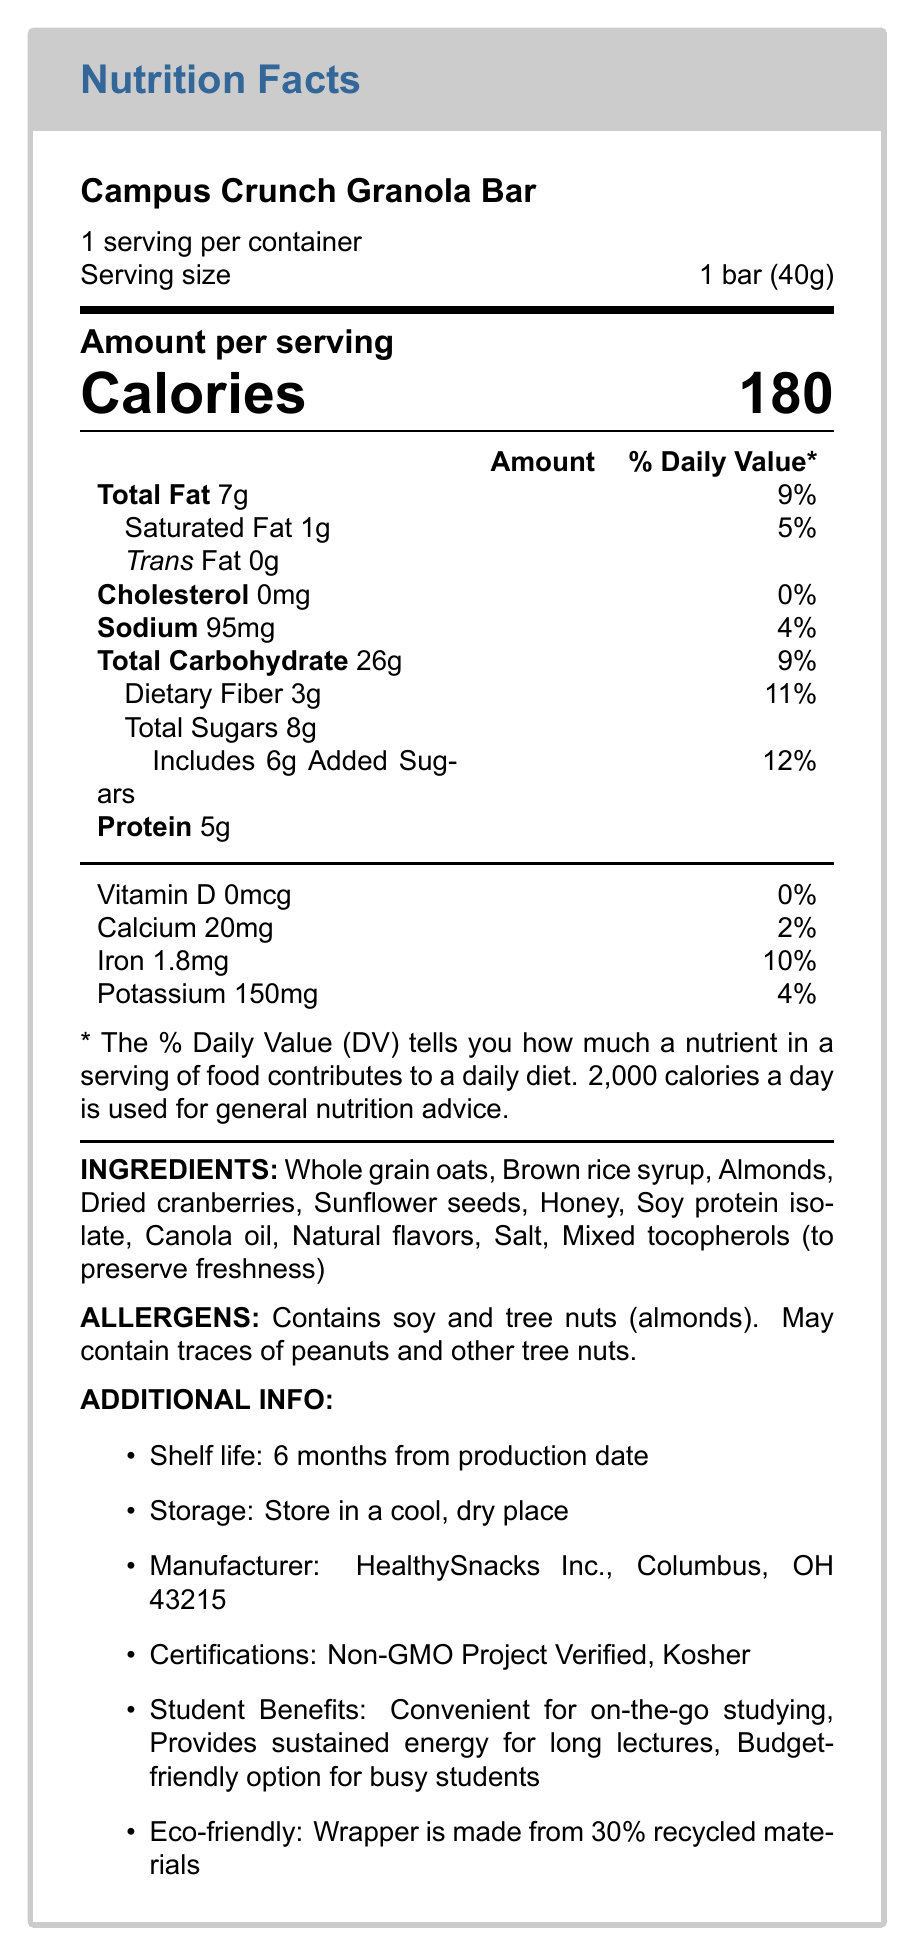what is the serving size? The serving size is explicitly stated as "1 bar (40g)" in the document.
Answer: 1 bar (40g) how many servings per container are there? The document indicates that there are "6 servings per container".
Answer: 6 how many grams of protein are in one serving? The document lists the protein content per serving as "5g".
Answer: 5g what is the total carbohydrate content in one serving? The nutritional information section shows that the total carbohydrate content is "26g".
Answer: 26g which nutrient has the highest daily value percentage? Among the nutrients listed, Dietary Fiber has the highest daily value percentage at "11%".
Answer: Dietary Fiber with 11% how many calories are in one serving? A. 160 B. 180 C. 200 D. 220 The document clearly shows that each serving contains "180" calories.
Answer: B what is the allergen information for this product? A. Contains milk and soy B. Contains soy and tree nuts C. Contains gluten and dairy The allergen section states that it contains "soy and tree nuts (almonds)".
Answer: B is the product eco-friendly? The document mentions that the wrapper is made from "30% recycled materials", indicating its eco-friendliness.
Answer: Yes is calcium content significant in this product? The calcium content is only "20mg", which is 2% of the daily value, suggesting it is not a significant source of calcium.
Answer: No summarize the main idea of the document. The main idea encapsulates the detailed nutritional information and other relevant details needed to understand the nutritional profile and benefits of the "Campus Crunch Granola Bar".
Answer: The document is a comprehensive Nutrition Facts Label for "Campus Crunch Granola Bar". It includes details about serving size, calories, macronutrient content, vitamins, minerals, ingredients, allergens, additional information such as the manufacturer, shelf life, storage, certifications, and benefits for students. does this product contain any cholesterol? The nutritional information indicates that the cholesterol content is "0mg" and 0% of the daily value.
Answer: No what are the main ingredients in this granola bar? The document lists these items under the "Ingredients" section.
Answer: Whole grain oats, Brown rice syrup, Almonds, Dried cranberries, Sunflower seeds, Honey, Soy protein isolate, Canola oil, Natural flavors, Salt, Mixed tocopherols. how much added sugars does one serving contain? The nutritional information specifies "6g" of added sugars per serving.
Answer: 6g what are the benefits for students consuming this product? The document lists these student benefits under the "Additional Info" section.
Answer: Convenient for on-the-go studying, Provides sustained energy for long lectures, Budget-friendly option for busy students who is the manufacturer of the Campus Crunch Granola Bar? The "Additional Info" section specifies the manufacturer as "HealthySnacks Inc., Columbus, OH 43215".
Answer: HealthySnacks Inc., Columbus, OH 43215 based on the document, can you determine the production date of the granola bar? The document mentions a shelf life of 6 months from the production date, but does not specify the exact production date.
Answer: Not enough information 